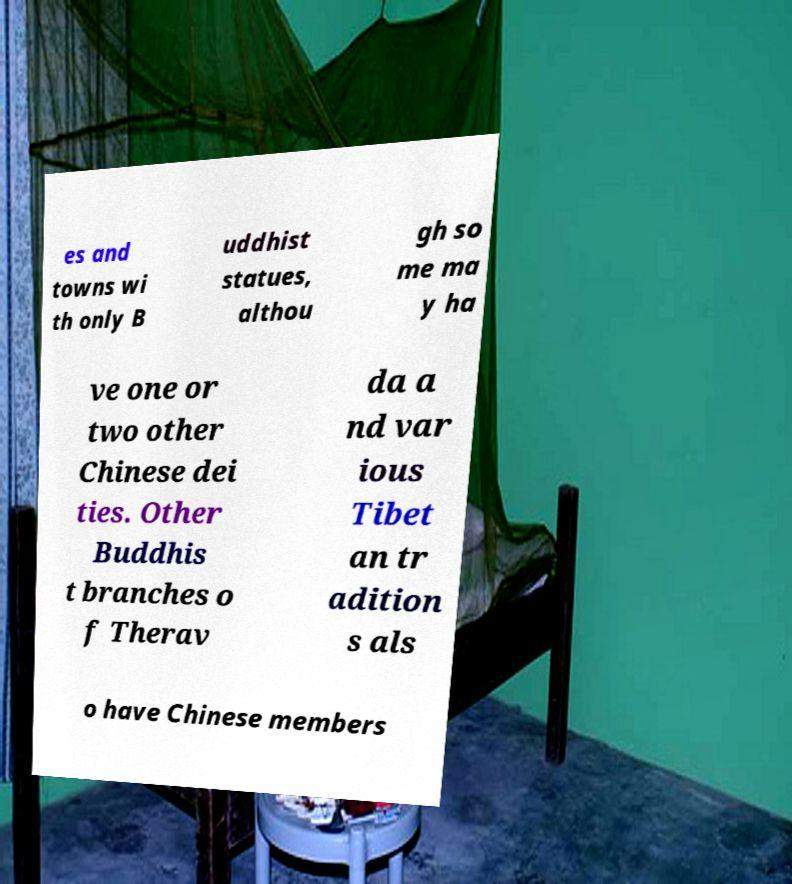Could you assist in decoding the text presented in this image and type it out clearly? es and towns wi th only B uddhist statues, althou gh so me ma y ha ve one or two other Chinese dei ties. Other Buddhis t branches o f Therav da a nd var ious Tibet an tr adition s als o have Chinese members 